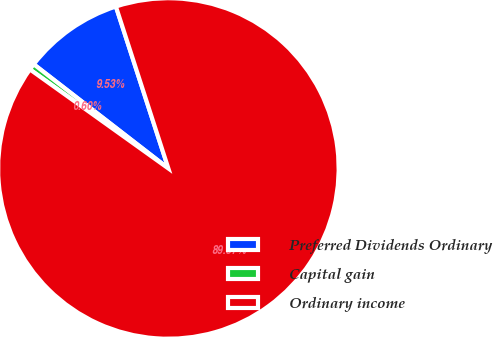<chart> <loc_0><loc_0><loc_500><loc_500><pie_chart><fcel>Preferred Dividends Ordinary<fcel>Capital gain<fcel>Ordinary income<nl><fcel>9.53%<fcel>0.6%<fcel>89.87%<nl></chart> 